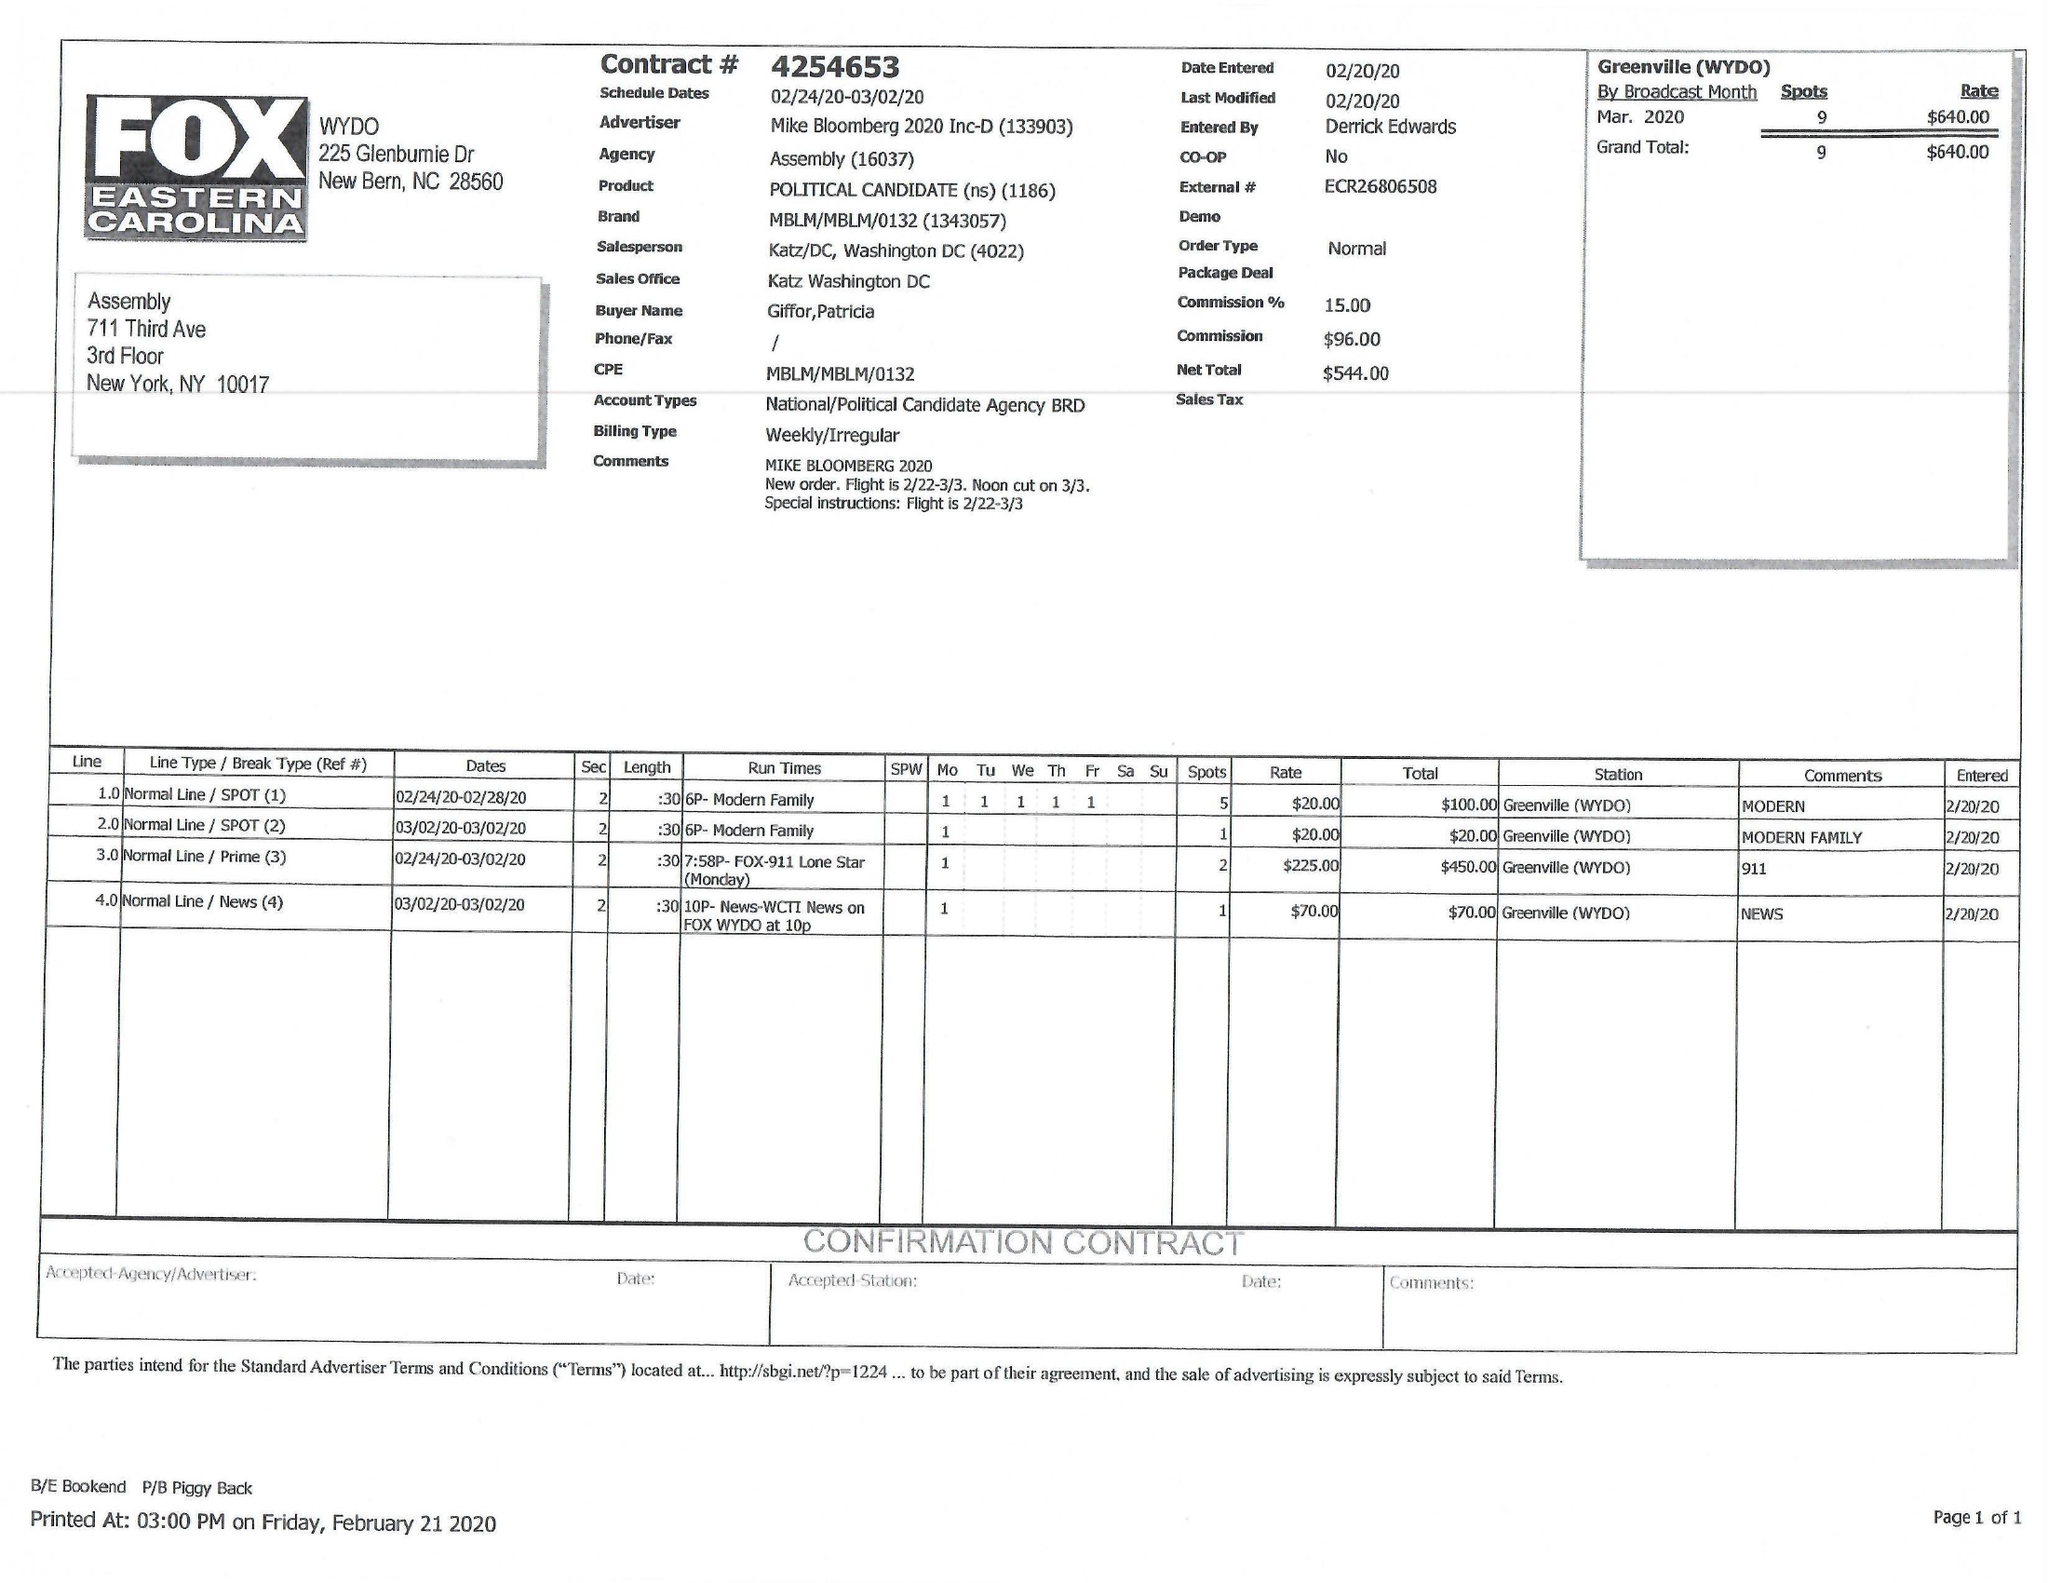What is the value for the contract_num?
Answer the question using a single word or phrase. 4254653 